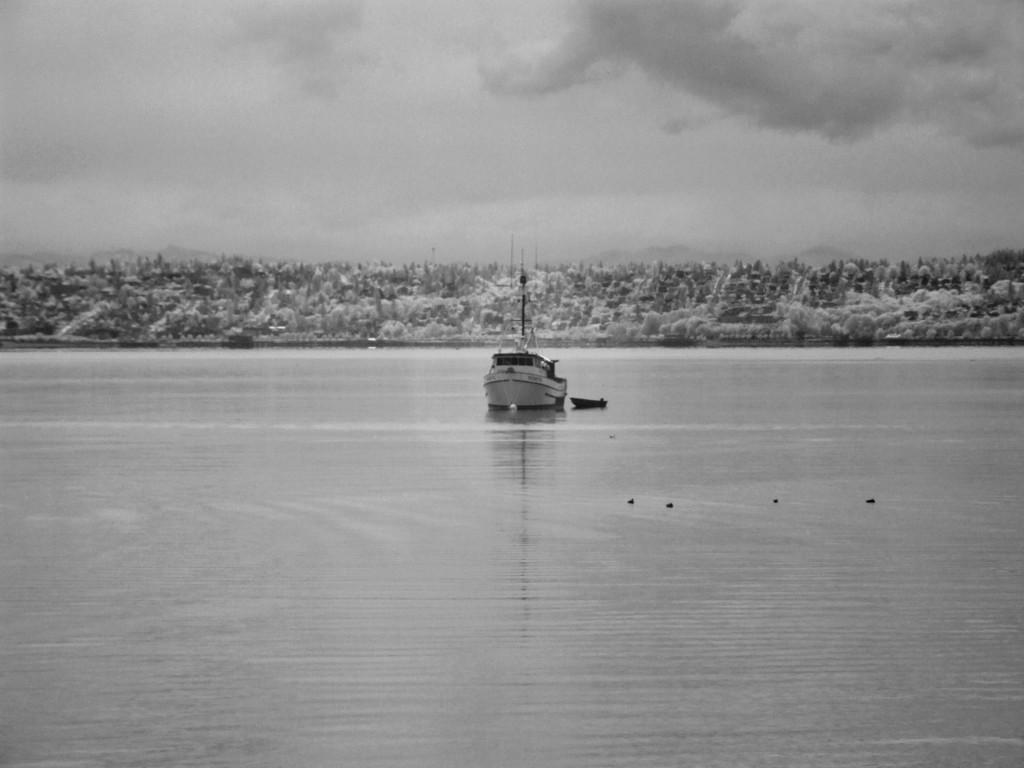What is the main subject of the image? The main subject of the image is water. What is located in the water? There is a ship in the water. What can be seen in the background of the image? There are trees in the background of the image. How would you describe the sky in the image? The sky is cloudy in the image. What is the tendency of the loaf to float in the water in the image? There is no loaf present in the image, so it is not possible to determine its tendency to float in the water. 